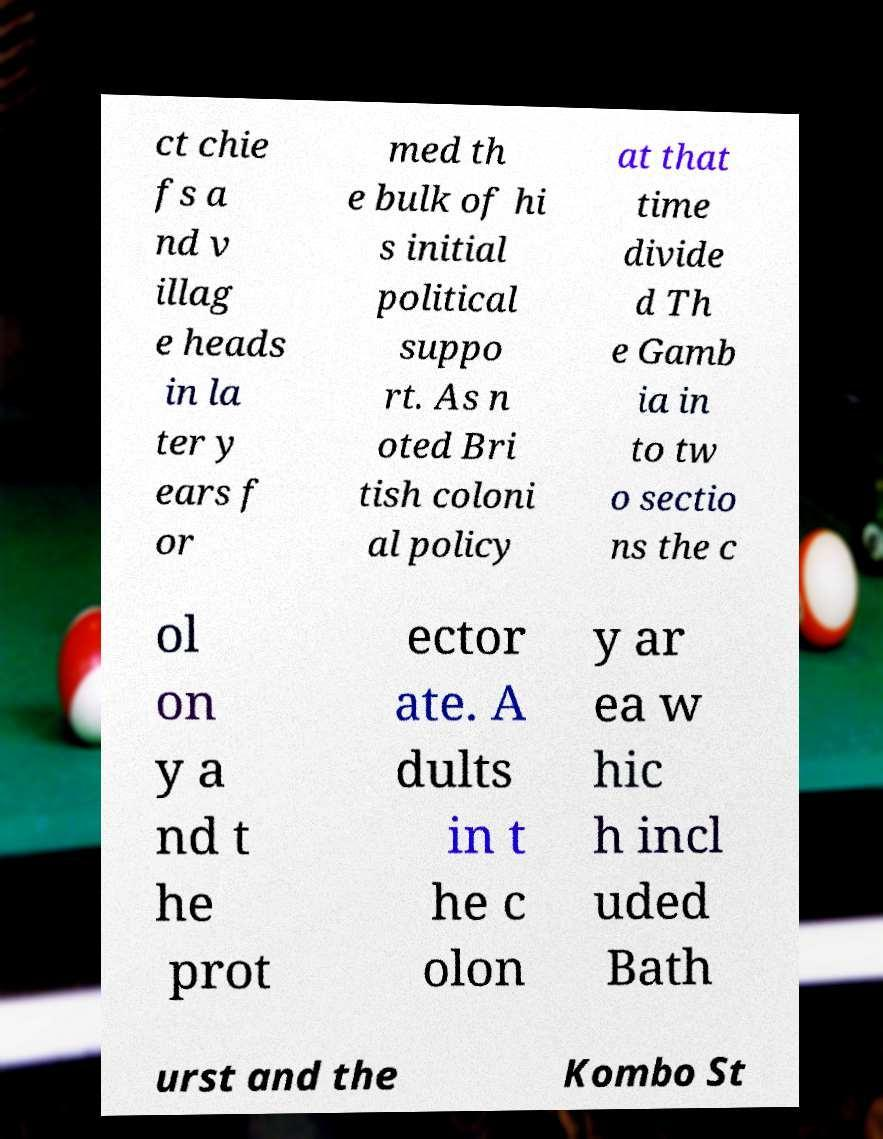Can you read and provide the text displayed in the image?This photo seems to have some interesting text. Can you extract and type it out for me? ct chie fs a nd v illag e heads in la ter y ears f or med th e bulk of hi s initial political suppo rt. As n oted Bri tish coloni al policy at that time divide d Th e Gamb ia in to tw o sectio ns the c ol on y a nd t he prot ector ate. A dults in t he c olon y ar ea w hic h incl uded Bath urst and the Kombo St 